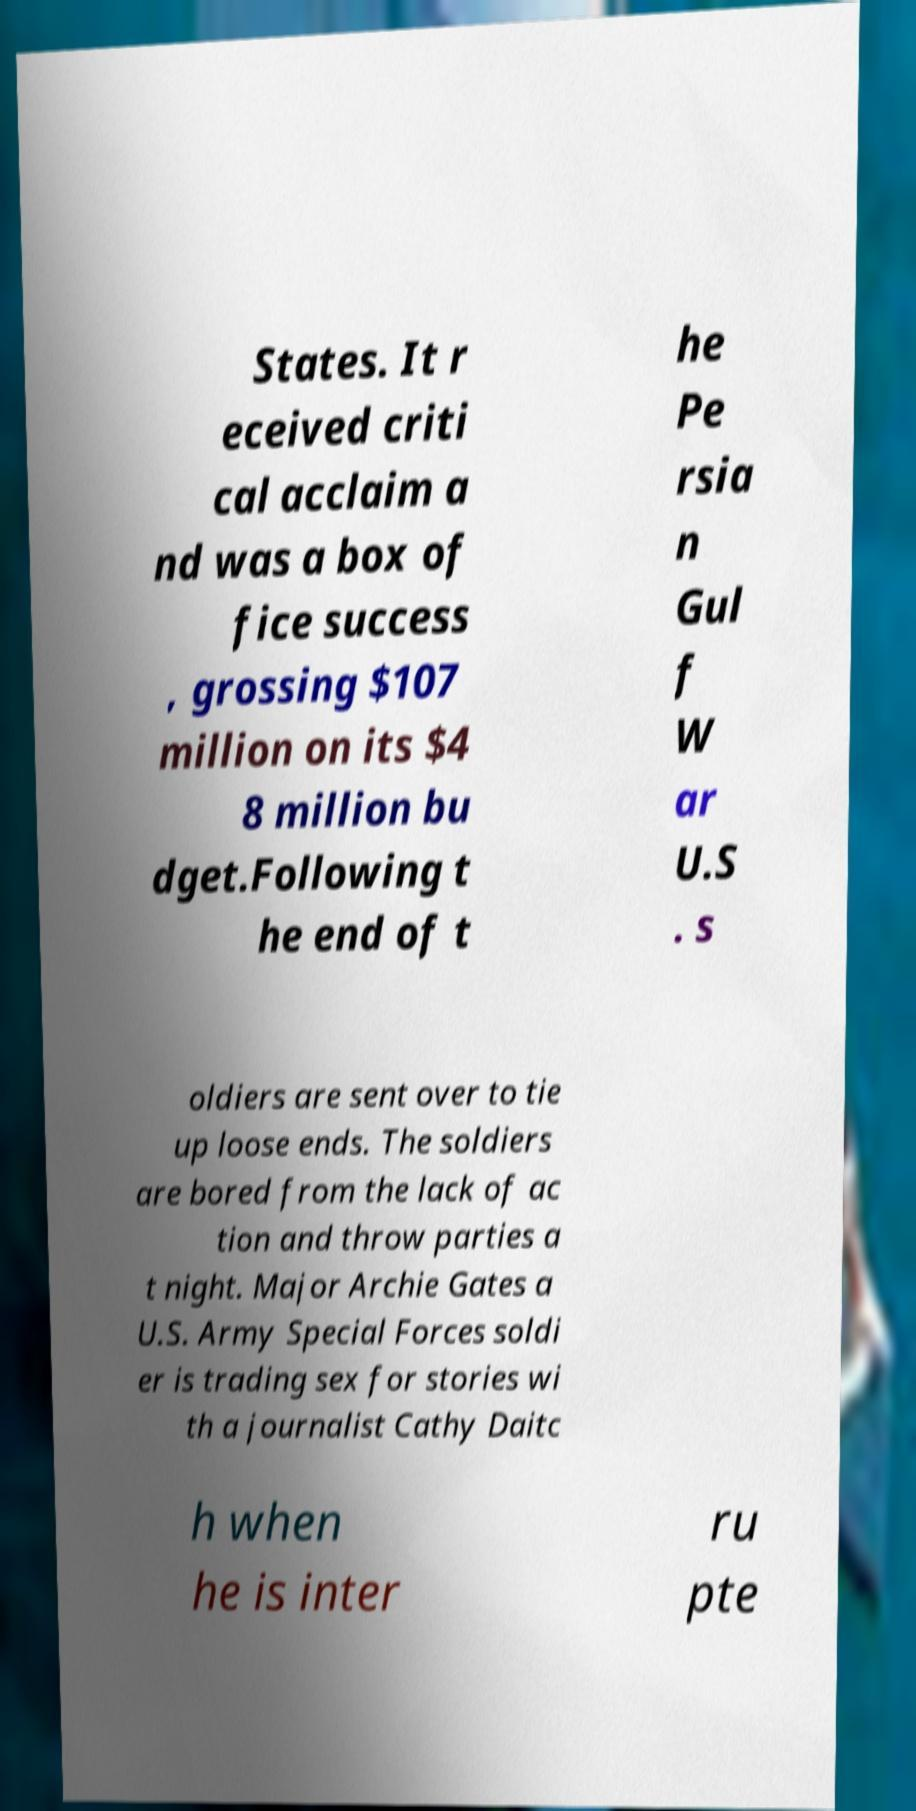Can you accurately transcribe the text from the provided image for me? States. It r eceived criti cal acclaim a nd was a box of fice success , grossing $107 million on its $4 8 million bu dget.Following t he end of t he Pe rsia n Gul f W ar U.S . s oldiers are sent over to tie up loose ends. The soldiers are bored from the lack of ac tion and throw parties a t night. Major Archie Gates a U.S. Army Special Forces soldi er is trading sex for stories wi th a journalist Cathy Daitc h when he is inter ru pte 